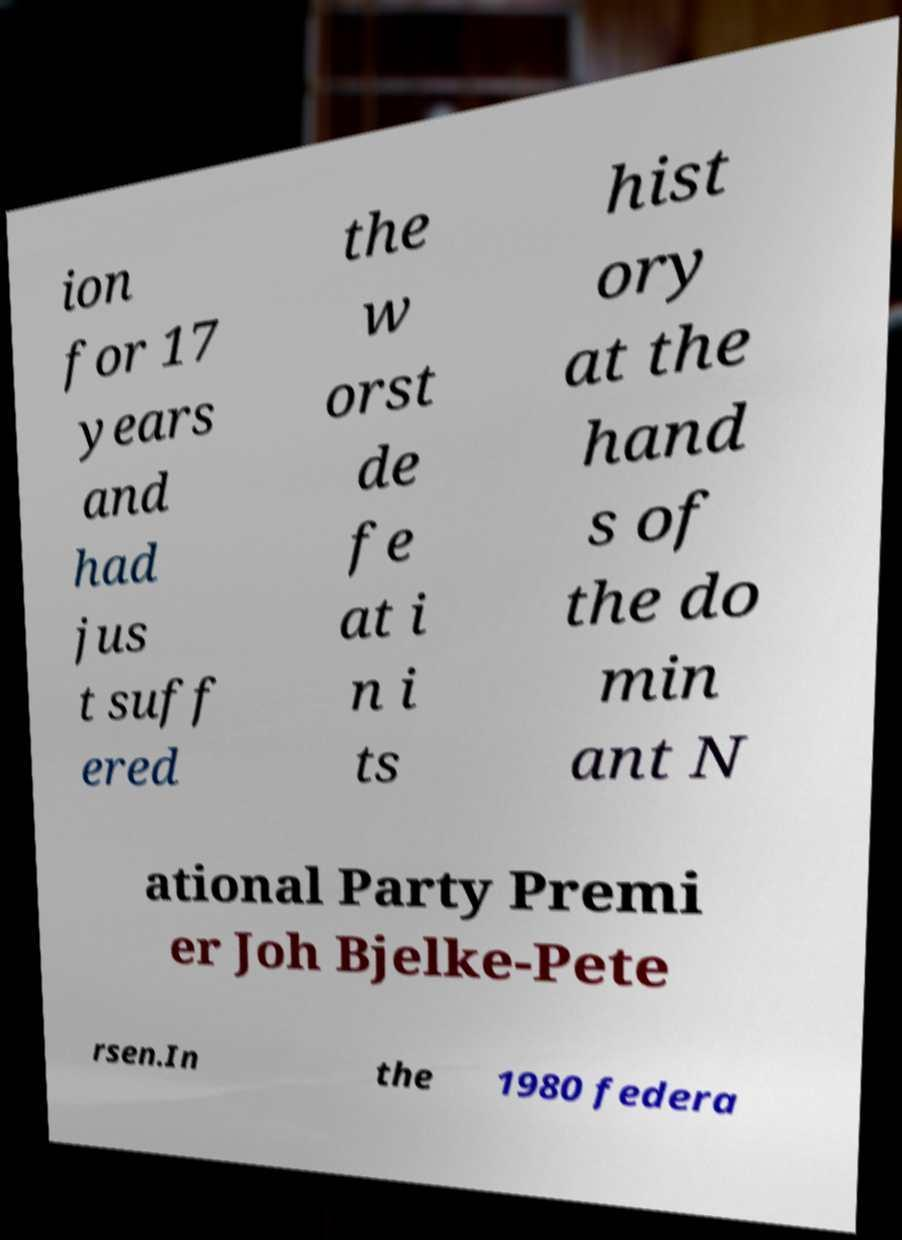There's text embedded in this image that I need extracted. Can you transcribe it verbatim? ion for 17 years and had jus t suff ered the w orst de fe at i n i ts hist ory at the hand s of the do min ant N ational Party Premi er Joh Bjelke-Pete rsen.In the 1980 federa 